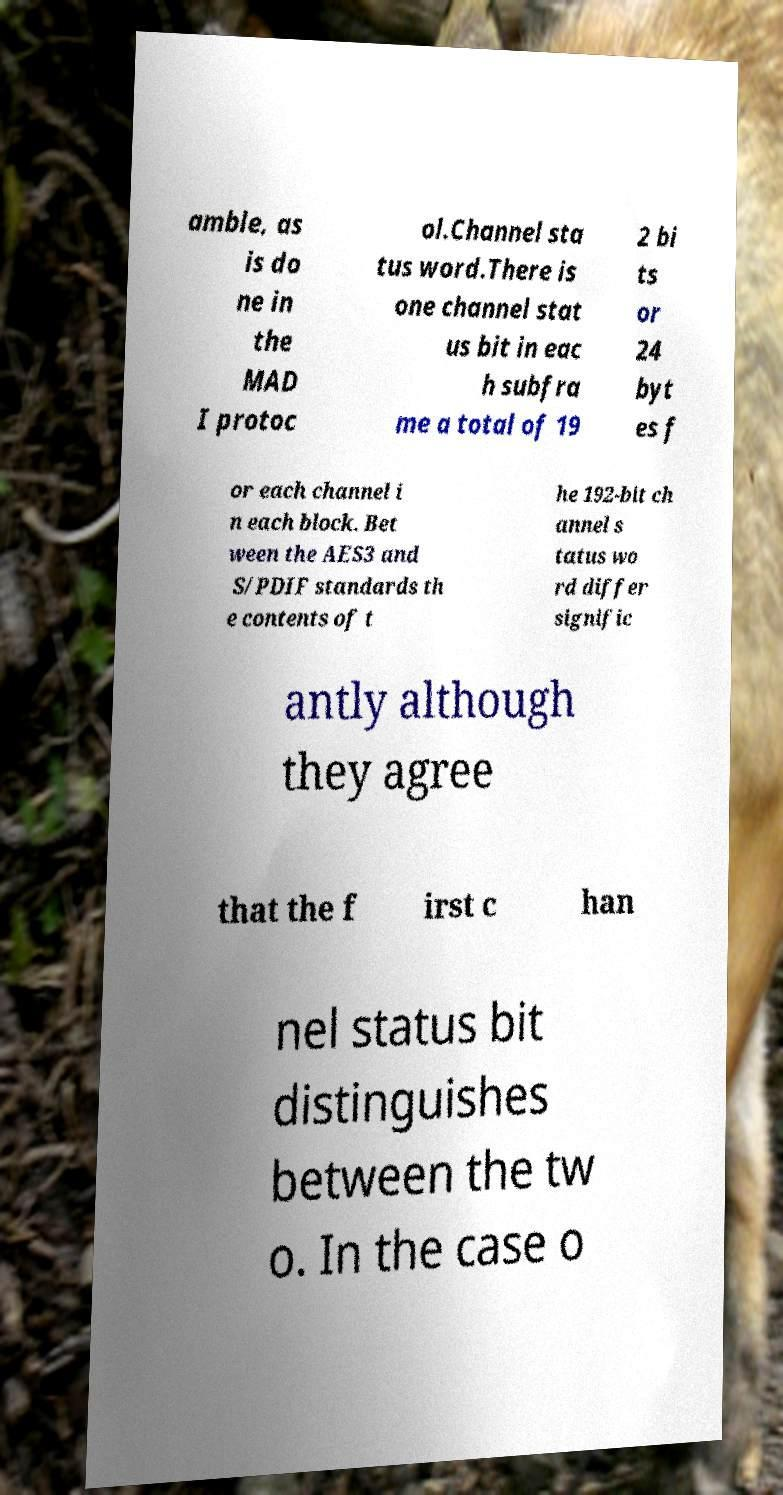Please identify and transcribe the text found in this image. amble, as is do ne in the MAD I protoc ol.Channel sta tus word.There is one channel stat us bit in eac h subfra me a total of 19 2 bi ts or 24 byt es f or each channel i n each block. Bet ween the AES3 and S/PDIF standards th e contents of t he 192-bit ch annel s tatus wo rd differ signific antly although they agree that the f irst c han nel status bit distinguishes between the tw o. In the case o 